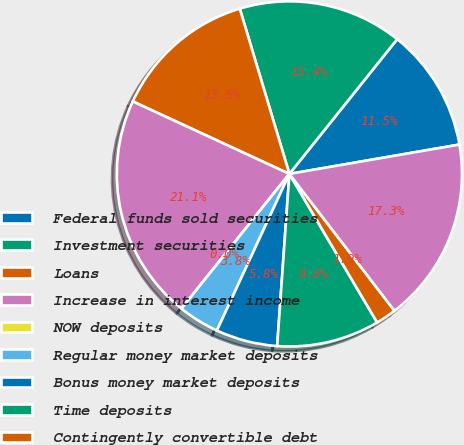Convert chart. <chart><loc_0><loc_0><loc_500><loc_500><pie_chart><fcel>Federal funds sold securities<fcel>Investment securities<fcel>Loans<fcel>Increase in interest income<fcel>NOW deposits<fcel>Regular money market deposits<fcel>Bonus money market deposits<fcel>Time deposits<fcel>Contingently convertible debt<fcel>Junior subordinated debentures<nl><fcel>11.54%<fcel>15.38%<fcel>13.46%<fcel>21.15%<fcel>0.0%<fcel>3.85%<fcel>5.77%<fcel>9.62%<fcel>1.93%<fcel>17.3%<nl></chart> 